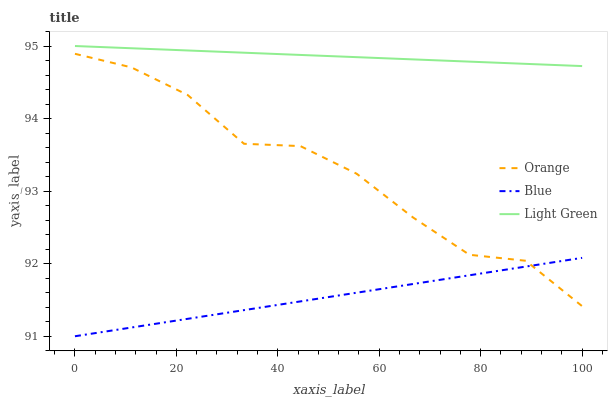Does Blue have the minimum area under the curve?
Answer yes or no. Yes. Does Light Green have the maximum area under the curve?
Answer yes or no. Yes. Does Light Green have the minimum area under the curve?
Answer yes or no. No. Does Blue have the maximum area under the curve?
Answer yes or no. No. Is Light Green the smoothest?
Answer yes or no. Yes. Is Orange the roughest?
Answer yes or no. Yes. Is Blue the smoothest?
Answer yes or no. No. Is Blue the roughest?
Answer yes or no. No. Does Blue have the lowest value?
Answer yes or no. Yes. Does Light Green have the lowest value?
Answer yes or no. No. Does Light Green have the highest value?
Answer yes or no. Yes. Does Blue have the highest value?
Answer yes or no. No. Is Orange less than Light Green?
Answer yes or no. Yes. Is Light Green greater than Orange?
Answer yes or no. Yes. Does Orange intersect Blue?
Answer yes or no. Yes. Is Orange less than Blue?
Answer yes or no. No. Is Orange greater than Blue?
Answer yes or no. No. Does Orange intersect Light Green?
Answer yes or no. No. 